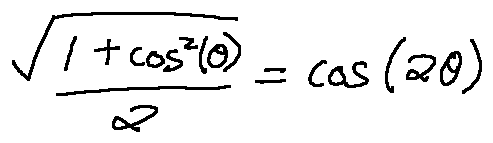Convert formula to latex. <formula><loc_0><loc_0><loc_500><loc_500>\frac { \sqrt { 1 + \cos ^ { 2 } ( \theta ) } } { 2 } = \cos ( 2 \theta )</formula> 